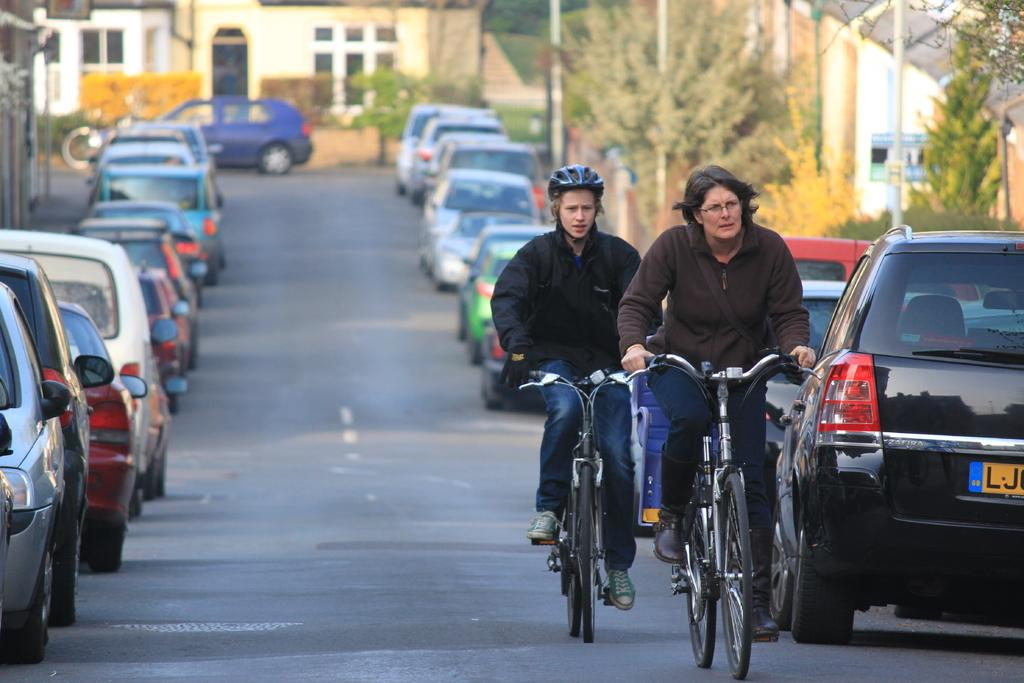What type of structures can be seen in the image? There are buildings in the image. What feature of the buildings is visible in the image? There are windows visible in the image. What type of vegetation is present in the image? There are trees in the image. What type of vertical structures can be seen in the image? There are poles in the image. What type of transportation is present on the road in the image? There are vehicles on the road in the image. What activity are two people engaged in within the image? Two people are riding bicycles in the image. What arithmetic problem is being solved by the trees in the image? There is no arithmetic problem being solved by the trees in the image; they are simply trees. What committee is responsible for maintaining the poles in the image? There is no committee mentioned or implied in the image; the poles are simply present. 